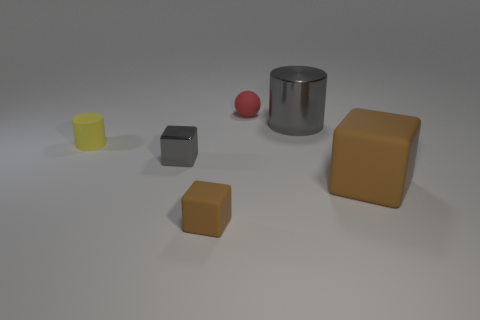Subtract all small blocks. How many blocks are left? 1 Subtract all gray cubes. How many cubes are left? 2 Add 1 large rubber blocks. How many objects exist? 7 Subtract all cylinders. How many objects are left? 4 Subtract 1 spheres. How many spheres are left? 0 Subtract all gray spheres. How many blue cylinders are left? 0 Subtract all tiny yellow matte cylinders. Subtract all gray metallic cylinders. How many objects are left? 4 Add 3 metal things. How many metal things are left? 5 Add 6 tiny brown blocks. How many tiny brown blocks exist? 7 Subtract 0 purple cylinders. How many objects are left? 6 